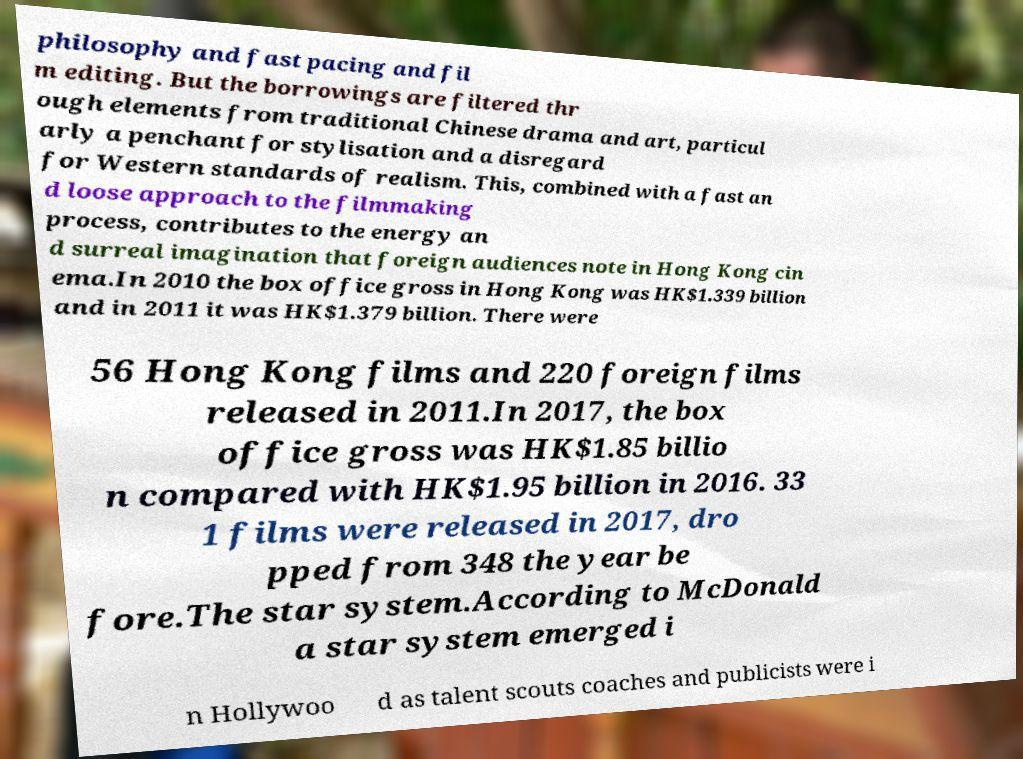Could you extract and type out the text from this image? philosophy and fast pacing and fil m editing. But the borrowings are filtered thr ough elements from traditional Chinese drama and art, particul arly a penchant for stylisation and a disregard for Western standards of realism. This, combined with a fast an d loose approach to the filmmaking process, contributes to the energy an d surreal imagination that foreign audiences note in Hong Kong cin ema.In 2010 the box office gross in Hong Kong was HK$1.339 billion and in 2011 it was HK$1.379 billion. There were 56 Hong Kong films and 220 foreign films released in 2011.In 2017, the box office gross was HK$1.85 billio n compared with HK$1.95 billion in 2016. 33 1 films were released in 2017, dro pped from 348 the year be fore.The star system.According to McDonald a star system emerged i n Hollywoo d as talent scouts coaches and publicists were i 